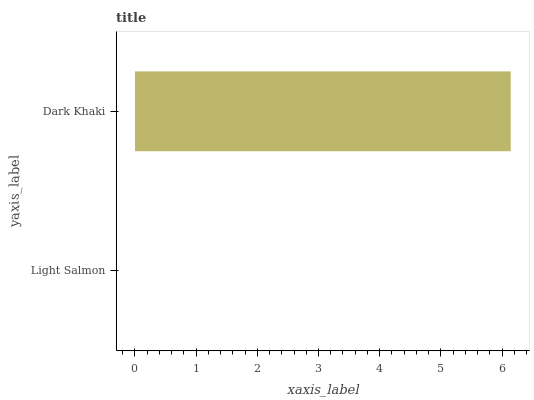Is Light Salmon the minimum?
Answer yes or no. Yes. Is Dark Khaki the maximum?
Answer yes or no. Yes. Is Dark Khaki the minimum?
Answer yes or no. No. Is Dark Khaki greater than Light Salmon?
Answer yes or no. Yes. Is Light Salmon less than Dark Khaki?
Answer yes or no. Yes. Is Light Salmon greater than Dark Khaki?
Answer yes or no. No. Is Dark Khaki less than Light Salmon?
Answer yes or no. No. Is Dark Khaki the high median?
Answer yes or no. Yes. Is Light Salmon the low median?
Answer yes or no. Yes. Is Light Salmon the high median?
Answer yes or no. No. Is Dark Khaki the low median?
Answer yes or no. No. 